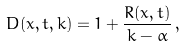<formula> <loc_0><loc_0><loc_500><loc_500>D ( x , t , k ) = 1 + \frac { R ( x , t ) } { k - \alpha } \, ,</formula> 